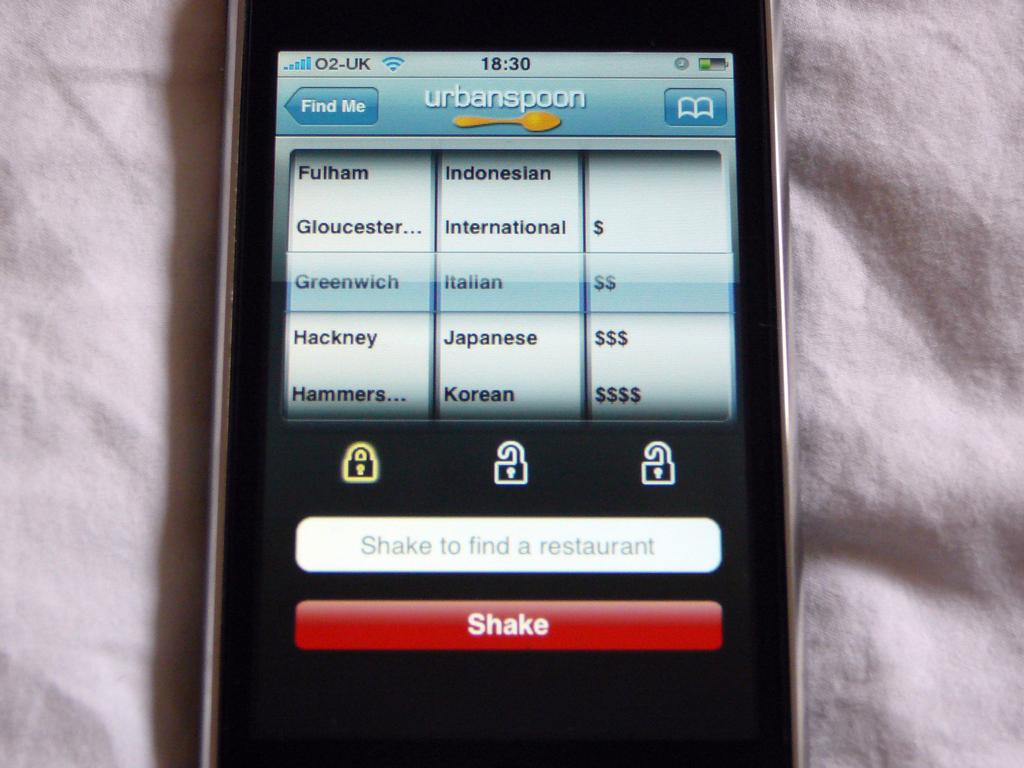<image>
Provide a brief description of the given image. A cellphone shows the urbanspoon site on its display screen. 